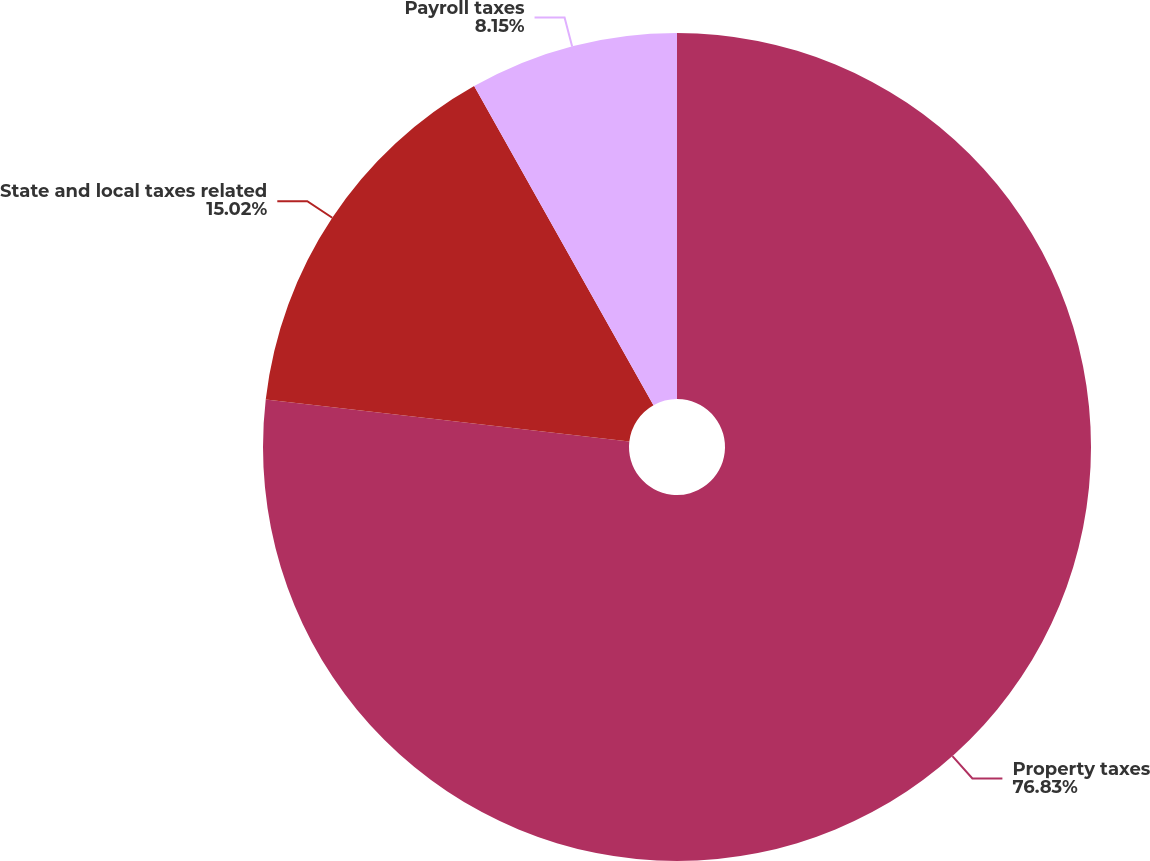<chart> <loc_0><loc_0><loc_500><loc_500><pie_chart><fcel>Property taxes<fcel>State and local taxes related<fcel>Payroll taxes<nl><fcel>76.83%<fcel>15.02%<fcel>8.15%<nl></chart> 